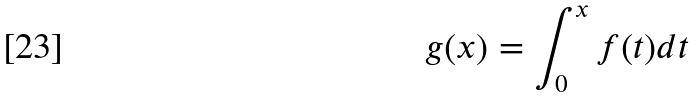<formula> <loc_0><loc_0><loc_500><loc_500>g ( x ) = \int _ { 0 } ^ { x } f ( t ) d t</formula> 